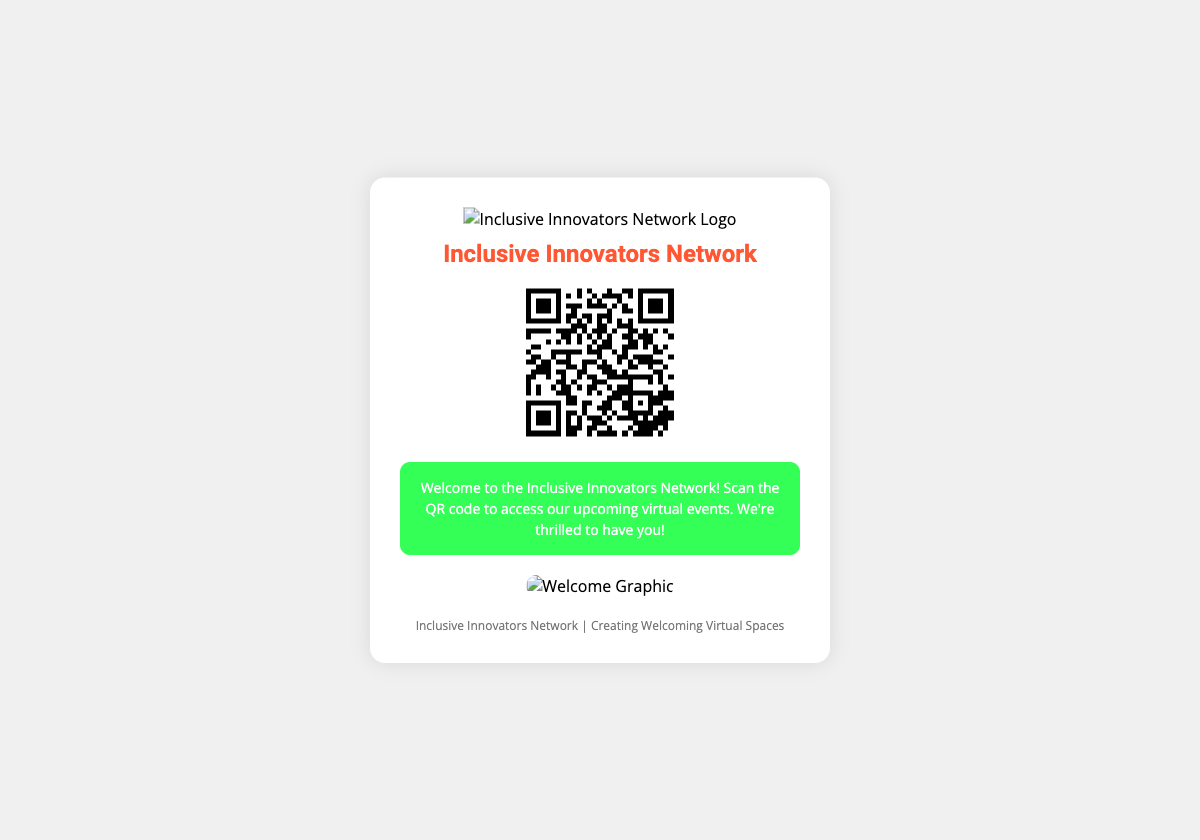What is the name of the network? The document states the network's name prominently at the top of the shipping label.
Answer: Inclusive Innovators Network What does the QR code provide access to? The QR code in the document is linked to a specific URL, which indicates it is for virtual event access.
Answer: Virtual event access What is the primary color used in the headings? The document shows the heading in a distinctive color which sets it apart, making it easy to identify.
Answer: #FF5733 What type of design is used for the message background? The document describes a particular background color for the message area to make it stand out.
Answer: #33FF57 What is the size of the QR code image? The document specifies the dimensions of the QR code image as displayed.
Answer: 150x150 How many graphics are included in the label? The document mentions specific graphics that are included to enhance the aesthetic of the shipping label.
Answer: One What does the footer emphasize? The footer of the document includes a message that emphasizes the network's mission.
Answer: Creating Welcoming Virtual Spaces What aspect of the recipient does the label acknowledge? The label contains a personalized message which indicates appreciation for the recipient's joining the network.
Answer: Welcome What type of artwork is emphasized in the shipping label? The document specifies the nature of the artwork present in the graphics section for appeal.
Answer: Colorful artwork 